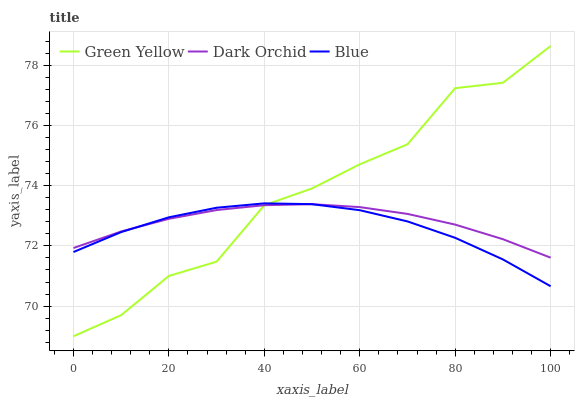Does Blue have the minimum area under the curve?
Answer yes or no. Yes. Does Green Yellow have the maximum area under the curve?
Answer yes or no. Yes. Does Dark Orchid have the minimum area under the curve?
Answer yes or no. No. Does Dark Orchid have the maximum area under the curve?
Answer yes or no. No. Is Dark Orchid the smoothest?
Answer yes or no. Yes. Is Green Yellow the roughest?
Answer yes or no. Yes. Is Green Yellow the smoothest?
Answer yes or no. No. Is Dark Orchid the roughest?
Answer yes or no. No. Does Green Yellow have the lowest value?
Answer yes or no. Yes. Does Dark Orchid have the lowest value?
Answer yes or no. No. Does Green Yellow have the highest value?
Answer yes or no. Yes. Does Dark Orchid have the highest value?
Answer yes or no. No. Does Green Yellow intersect Blue?
Answer yes or no. Yes. Is Green Yellow less than Blue?
Answer yes or no. No. Is Green Yellow greater than Blue?
Answer yes or no. No. 